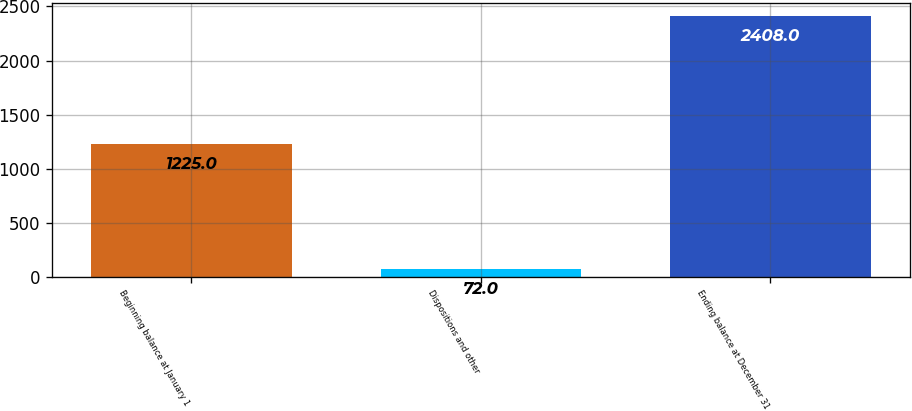<chart> <loc_0><loc_0><loc_500><loc_500><bar_chart><fcel>Beginning balance at January 1<fcel>Dispositions and other<fcel>Ending balance at December 31<nl><fcel>1225<fcel>72<fcel>2408<nl></chart> 